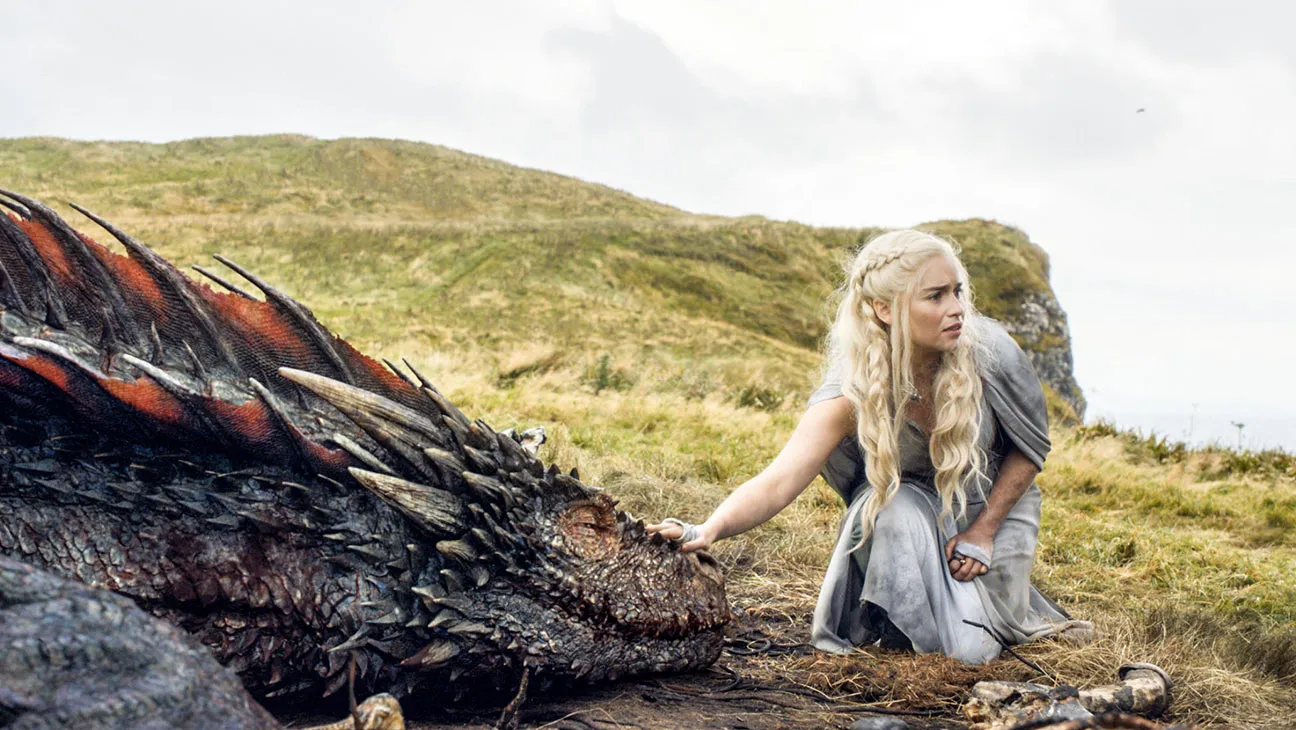Describe the following image. In this image, the character portrayed by Emilia Clarke, from "Game of Thrones", appears in a poignant moment with her dragon. The dragon's scales gleam with hues of red and black as it reclines on the grass, its majestic presence emphasized by intricate detailing of its scales and horns. The actress, clothed in a modest, pale gray dress, kneels beside the creature on a grassy knoll, her long, blonde hair flowing and adding to the ethereal quality of the scene. She extends her hand toward it with a gentle, yet concerned expression, indicating a deep bond between them. This moment captures an emotional depth, illustrating themes of companionship and loyalty amidst a fantasy setting. 